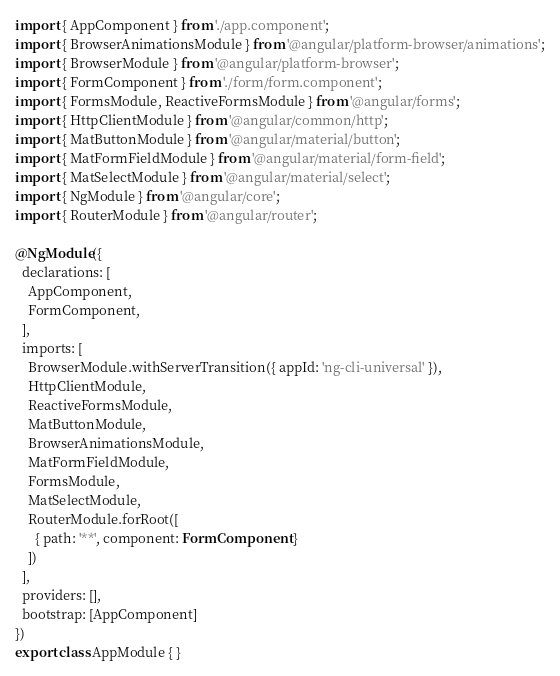Convert code to text. <code><loc_0><loc_0><loc_500><loc_500><_TypeScript_>import { AppComponent } from './app.component';
import { BrowserAnimationsModule } from '@angular/platform-browser/animations';
import { BrowserModule } from '@angular/platform-browser';
import { FormComponent } from './form/form.component';
import { FormsModule, ReactiveFormsModule } from '@angular/forms';
import { HttpClientModule } from '@angular/common/http';
import { MatButtonModule } from '@angular/material/button';
import { MatFormFieldModule } from '@angular/material/form-field';
import { MatSelectModule } from '@angular/material/select';
import { NgModule } from '@angular/core';
import { RouterModule } from '@angular/router';

@NgModule({
  declarations: [
    AppComponent,
    FormComponent,
  ],
  imports: [
    BrowserModule.withServerTransition({ appId: 'ng-cli-universal' }),
    HttpClientModule,
    ReactiveFormsModule,
    MatButtonModule,
    BrowserAnimationsModule,
    MatFormFieldModule,
    FormsModule,
    MatSelectModule,
    RouterModule.forRoot([
      { path: '**', component: FormComponent }
    ])
  ],
  providers: [],
  bootstrap: [AppComponent]
})
export class AppModule { }
</code> 